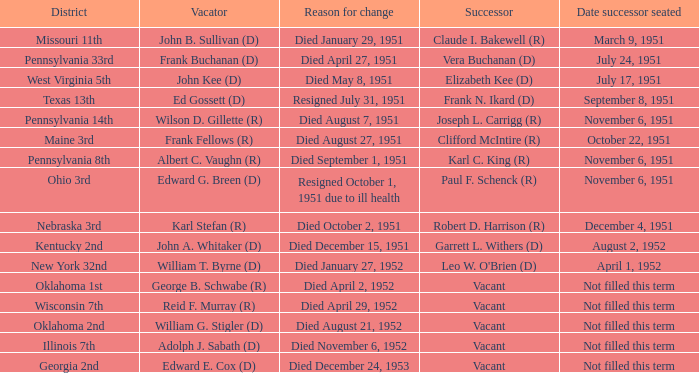How many vacators existed in the pennsylvania 33rd district? 1.0. 